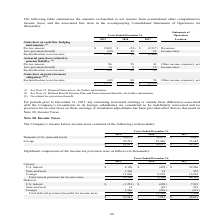According to Sykes Enterprises Incorporated's financial document, What was the total income before income taxes in 2019? According to the financial document, $85,923 (in thousands). The relevant text states: "$ 85,923 $ 56,917 $ 81,307..." Also, What was the  Foreign  income before income taxes in 2018? According to the financial document, 49,946 (in thousands). The relevant text states: "Foreign 47,251 49,946 71,645..." Also, What are the components under income before income taxes? The document shows two values: Domestic (U.S., state and local) and Foreign. From the document: "Domestic (U.S., state and local) $ 38,672 $ 6,971 $ 9,662 Foreign 47,251 49,946 71,645..." Additionally, In which year was income before income taxes the largest? According to the financial document, 2019. The relevant text states: "2019 2018 2017 Location..." Also, can you calculate: What was the change in Foreign in 2019 from 2018? Based on the calculation: 47,251-49,946, the result is -2695 (in thousands). This is based on the information: "Foreign 47,251 49,946 71,645 Foreign 47,251 49,946 71,645..." The key data points involved are: 47,251, 49,946. Also, can you calculate: What was the percentage change in Foreign income before income taxes in 2019 from 2018? To answer this question, I need to perform calculations using the financial data. The calculation is: (47,251-49,946)/49,946, which equals -5.4 (percentage). This is based on the information: "Foreign 47,251 49,946 71,645 Foreign 47,251 49,946 71,645..." The key data points involved are: 47,251, 49,946. 